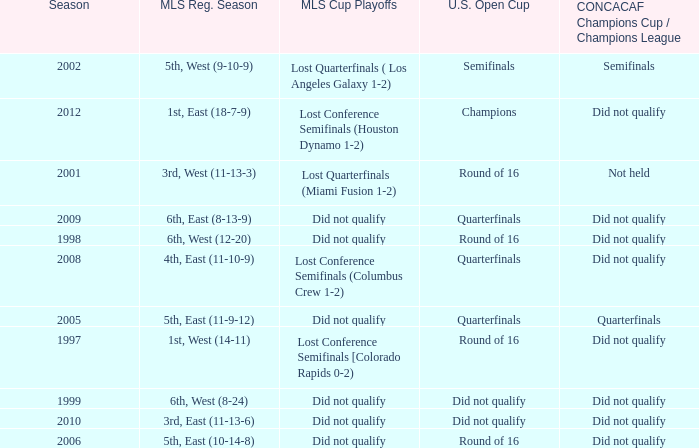When was the first season? 1997.0. 